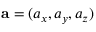Convert formula to latex. <formula><loc_0><loc_0><loc_500><loc_500>a = ( a _ { x } , a _ { y } , a _ { z } )</formula> 